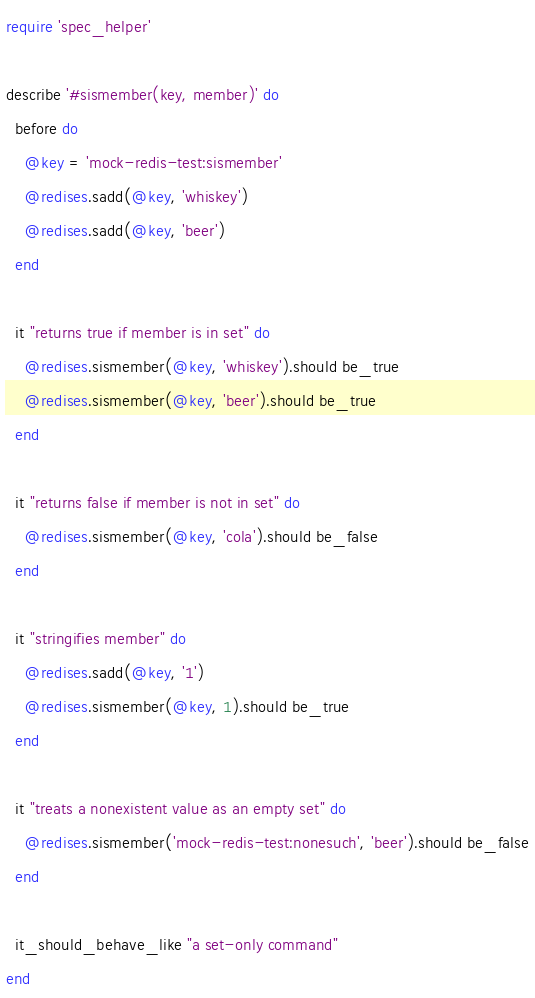Convert code to text. <code><loc_0><loc_0><loc_500><loc_500><_Ruby_>require 'spec_helper'

describe '#sismember(key, member)' do
  before do
    @key = 'mock-redis-test:sismember'
    @redises.sadd(@key, 'whiskey')
    @redises.sadd(@key, 'beer')
  end

  it "returns true if member is in set" do
    @redises.sismember(@key, 'whiskey').should be_true
    @redises.sismember(@key, 'beer').should be_true
  end

  it "returns false if member is not in set" do
    @redises.sismember(@key, 'cola').should be_false
  end

  it "stringifies member" do
    @redises.sadd(@key, '1')
    @redises.sismember(@key, 1).should be_true
  end

  it "treats a nonexistent value as an empty set" do
    @redises.sismember('mock-redis-test:nonesuch', 'beer').should be_false
  end

  it_should_behave_like "a set-only command"
end
</code> 